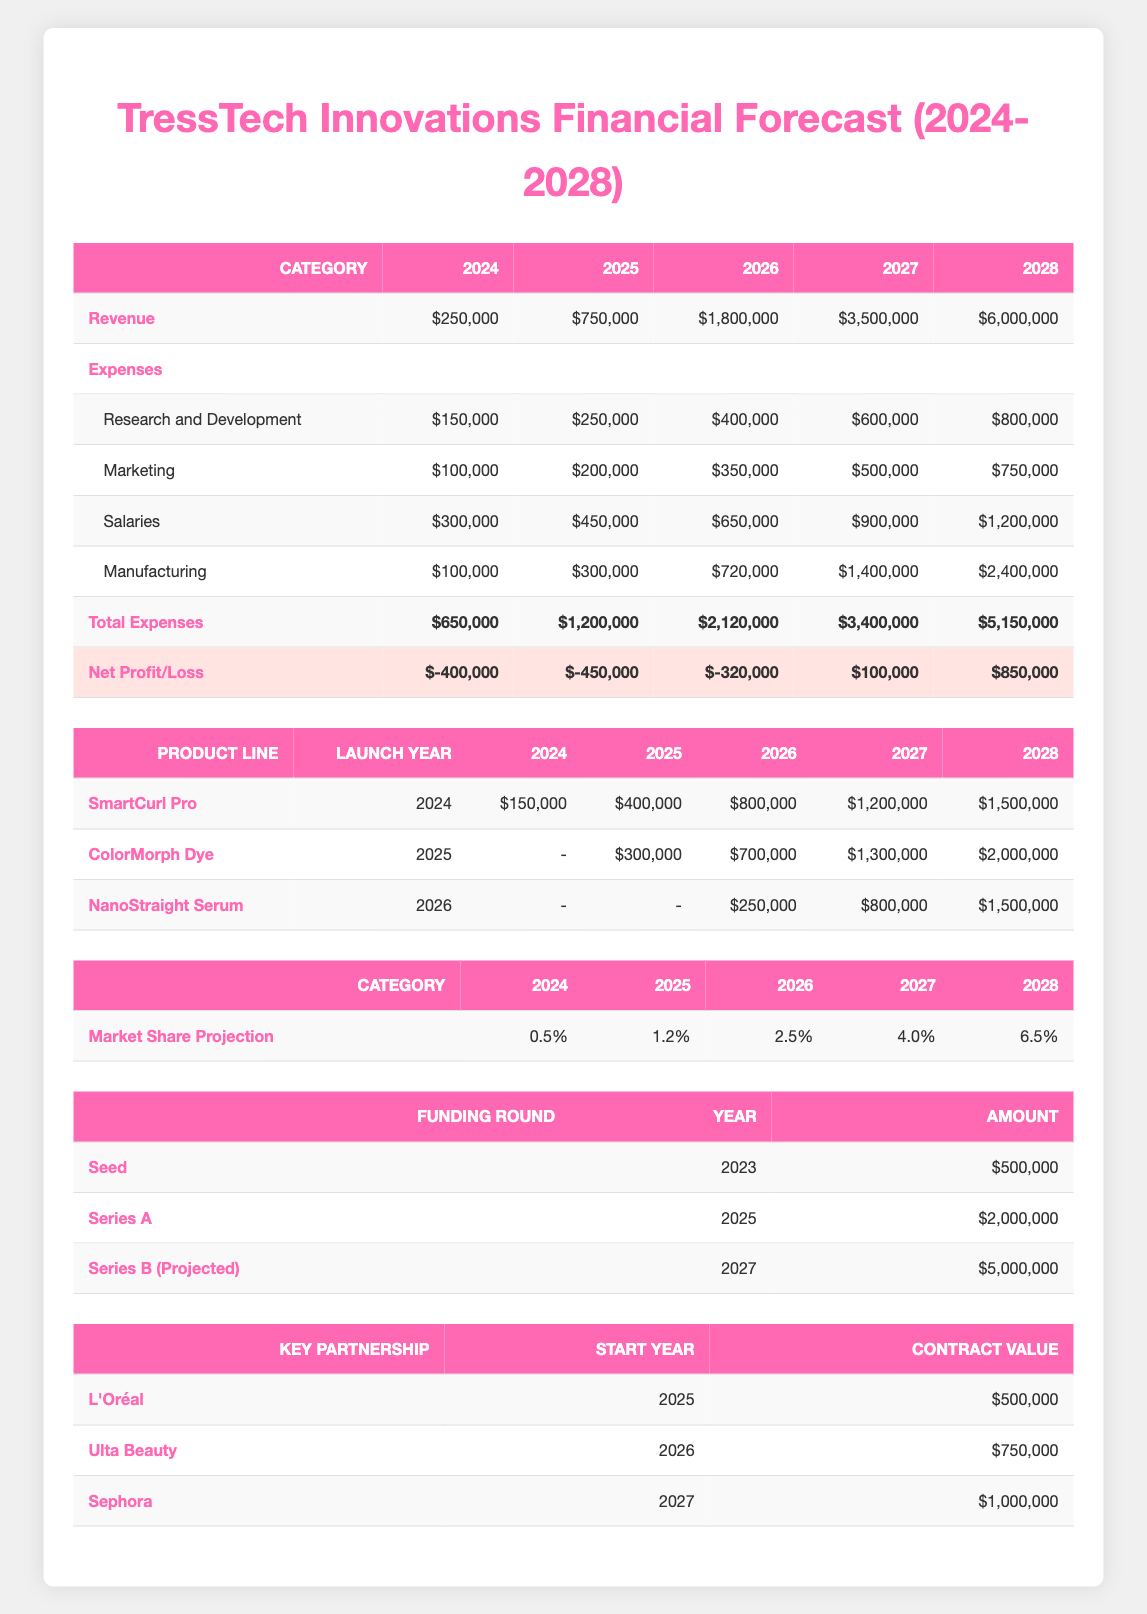What is the total revenue projected for 2026? The revenue for 2026 is listed directly in the table under the revenue category, which is 1,800,000.
Answer: 1,800,000 What are the total expenses for the year 2025? The total expenses for 2025 are displayed in the total expenses row, which shows 1,200,000 for that year.
Answer: 1,200,000 Is the net profit for 2027 projected to be positive or negative? In the net profit/loss row for 2027, the value is shown as 100,000, which is positive.
Answer: Positive What is the average projected sales from the SmartCurl Pro from 2024 to 2028? To find the average, we sum the projected sales for the SmartCurl Pro from the years 2024 (150,000), 2025 (400,000), 2026 (800,000), 2027 (1,200,000), and 2028 (1,500,000), which gives us a total of 3,050,000. Dividing by 5 gives us an average of 610,000.
Answer: 610,000 How much funding is projected from the Series B round in 2027? The table indicates that the projected amount for the Series B round in 2027 is 5,000,000.
Answer: 5,000,000 What percentage of market share is projected for 2028? The market share projection for 2028 is specifically mentioned in the table as 6.5%.
Answer: 6.5% Which product line is expected to launch in 2026? According to the product lines table, the NanoStraight Serum is expected to launch in 2026.
Answer: NanoStraight Serum What is the total amount of contract value from key partnerships starting in 2025? The contract values for key partnerships starting in 2025 are L'Oréal (500,000) and Ulta Beauty (750,000). Adding these values gives a total of 1,250,000.
Answer: 1,250,000 